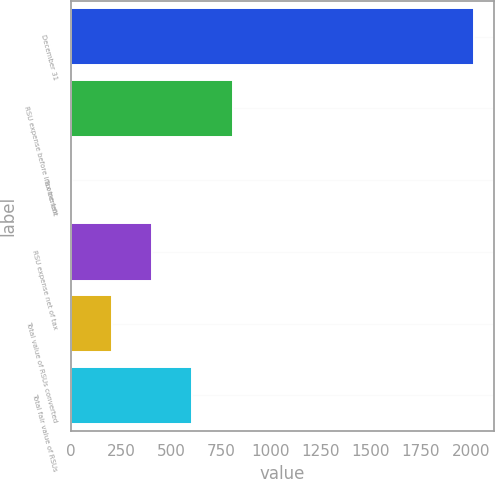Convert chart to OTSL. <chart><loc_0><loc_0><loc_500><loc_500><bar_chart><fcel>December 31<fcel>RSU expense before income tax<fcel>Tax benefit<fcel>RSU expense net of tax<fcel>Total value of RSUs converted<fcel>Total fair value of RSUs<nl><fcel>2016<fcel>808.8<fcel>4<fcel>406.4<fcel>205.2<fcel>607.6<nl></chart> 